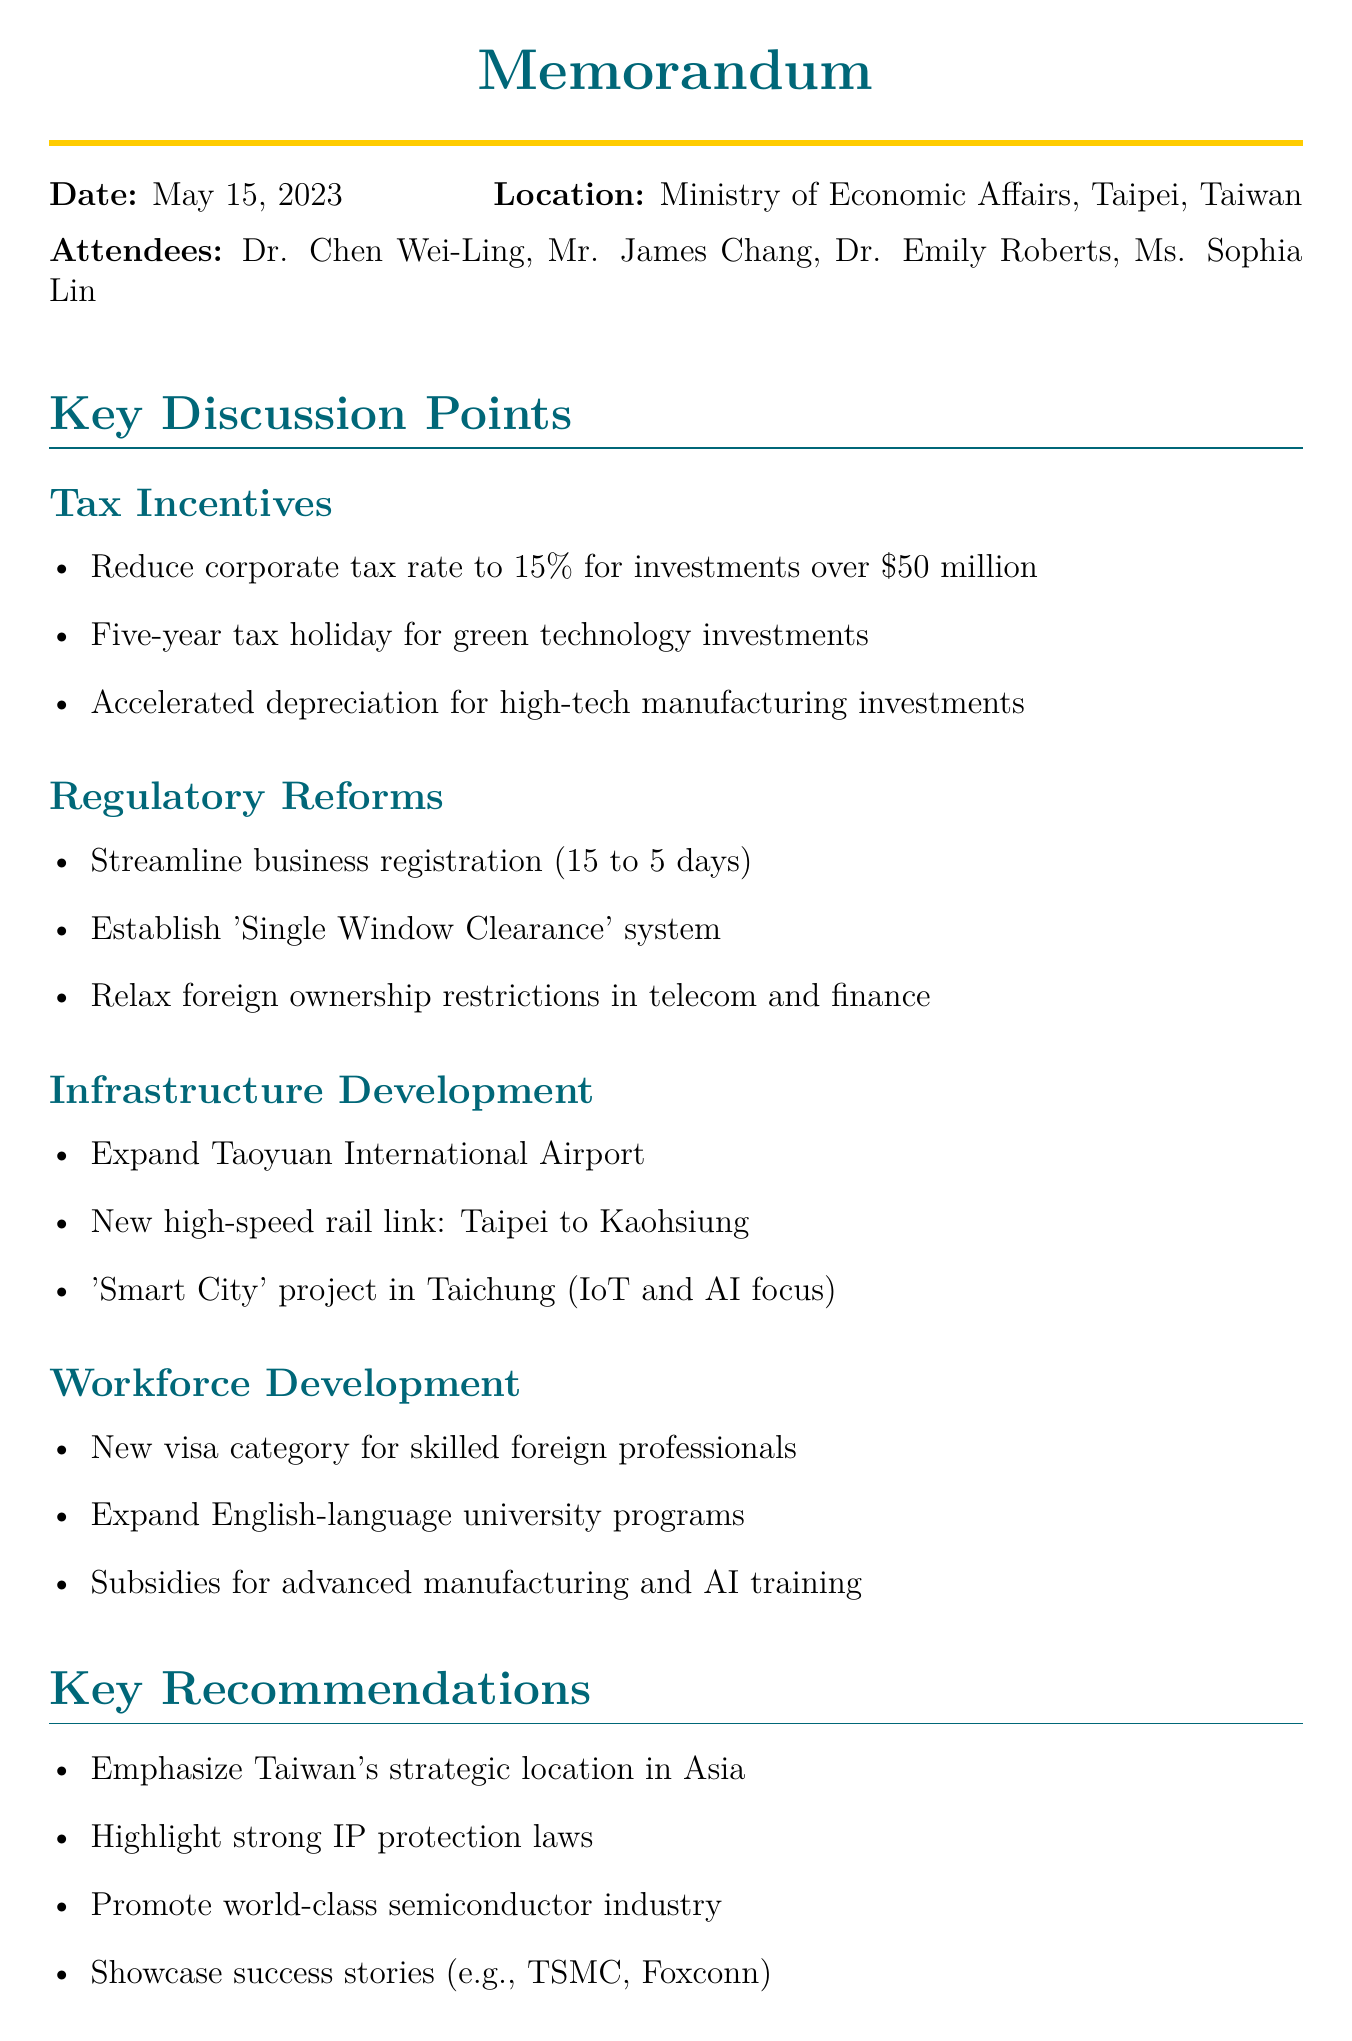What is the date of the meeting? The date of the meeting is directly mentioned in the document.
Answer: May 15, 2023 Who is the Minister of Economic Affairs? The name of the Minister of Economic Affairs is provided among the attendees.
Answer: Dr. Chen Wei-Ling What is one of the tax incentives proposed? The document lists proposed tax incentives under the discussion points.
Answer: Five-year tax holiday for investments in green technology and renewable energy sectors How long is the proposed tax holiday? The duration of the tax holiday is specified in the tax incentives section.
Answer: Five years What is the strategic location of Taiwan referred to in the recommendations? The key recommendations highlight Taiwan's strategic positioning related to markets.
Answer: Gateway to Asian markets What are companies encouraged to showcase in order to attract foreign investment? The document outlines specific actions recommended in the key recommendations section.
Answer: Success stories of foreign companies like TSMC and Foxconn What is one next step mentioned for the policy proposals? The document outlines specific next steps, including drafting deadlines.
Answer: Draft detailed policy proposals for cabinet review by June 30, 2023 What is one of the infrastructure development plans? The infrastructure development section details plans for enhancing transportation.
Answer: Expand Taoyuan International Airport What is the new work visa category focused on? The workforce development section defines the purpose of the new visa category.
Answer: Highly skilled foreign professionals 